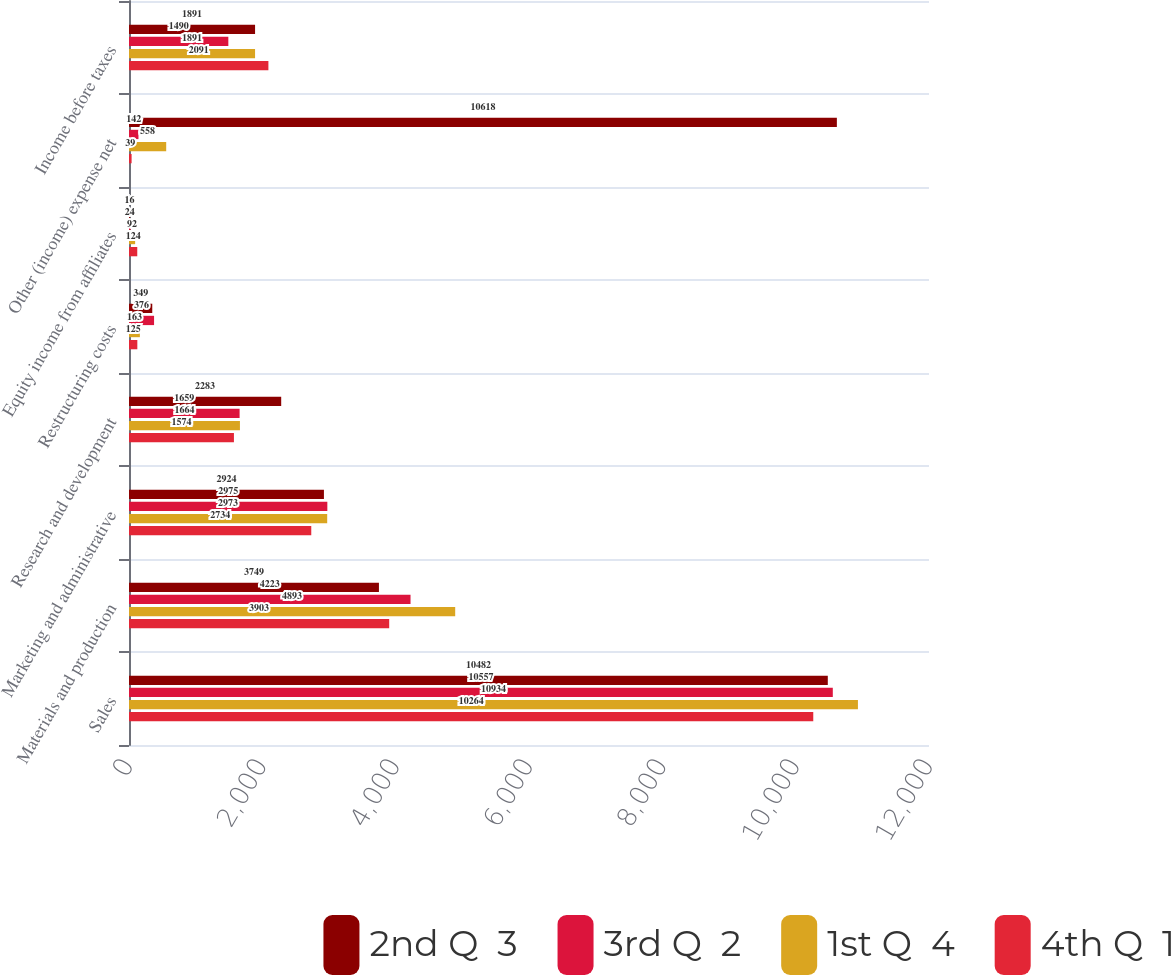<chart> <loc_0><loc_0><loc_500><loc_500><stacked_bar_chart><ecel><fcel>Sales<fcel>Materials and production<fcel>Marketing and administrative<fcel>Research and development<fcel>Restructuring costs<fcel>Equity income from affiliates<fcel>Other (income) expense net<fcel>Income before taxes<nl><fcel>2nd Q  3<fcel>10482<fcel>3749<fcel>2924<fcel>2283<fcel>349<fcel>16<fcel>10618<fcel>1891<nl><fcel>3rd Q  2<fcel>10557<fcel>4223<fcel>2975<fcel>1659<fcel>376<fcel>24<fcel>142<fcel>1490<nl><fcel>1st Q  4<fcel>10934<fcel>4893<fcel>2973<fcel>1664<fcel>163<fcel>92<fcel>558<fcel>1891<nl><fcel>4th Q  1<fcel>10264<fcel>3903<fcel>2734<fcel>1574<fcel>125<fcel>124<fcel>39<fcel>2091<nl></chart> 